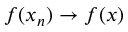<formula> <loc_0><loc_0><loc_500><loc_500>f ( x _ { n } ) \to f ( x )</formula> 